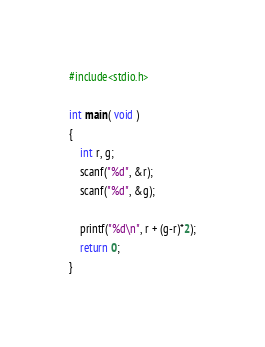<code> <loc_0><loc_0><loc_500><loc_500><_C_>#include<stdio.h>

int main( void )
{
    int r, g;
    scanf("%d", &r);
    scanf("%d", &g);

    printf("%d\n", r + (g-r)*2);
    return 0;
}</code> 